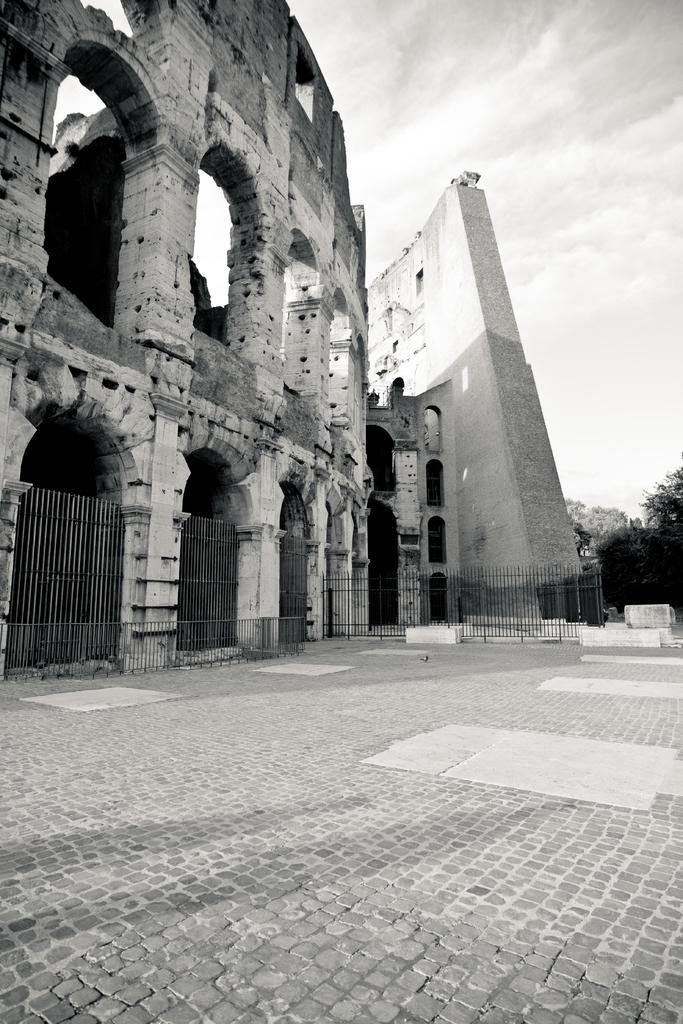How would you summarize this image in a sentence or two? This picture is clicked outside the city. Here, we see a building or a monument. Beside that, we see an iron railing. On the right corner of the picture, there are trees and at the top of the picture, we see the sky. At the bottom of the picture, we see a road which is made up of cobblestones. This is a black and white picture. 